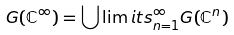<formula> <loc_0><loc_0><loc_500><loc_500>G ( { \mathbb { C } } ^ { \infty } ) = \bigcup \lim i t s _ { n = 1 } ^ { \infty } G ( { \mathbb { C } } ^ { n } )</formula> 